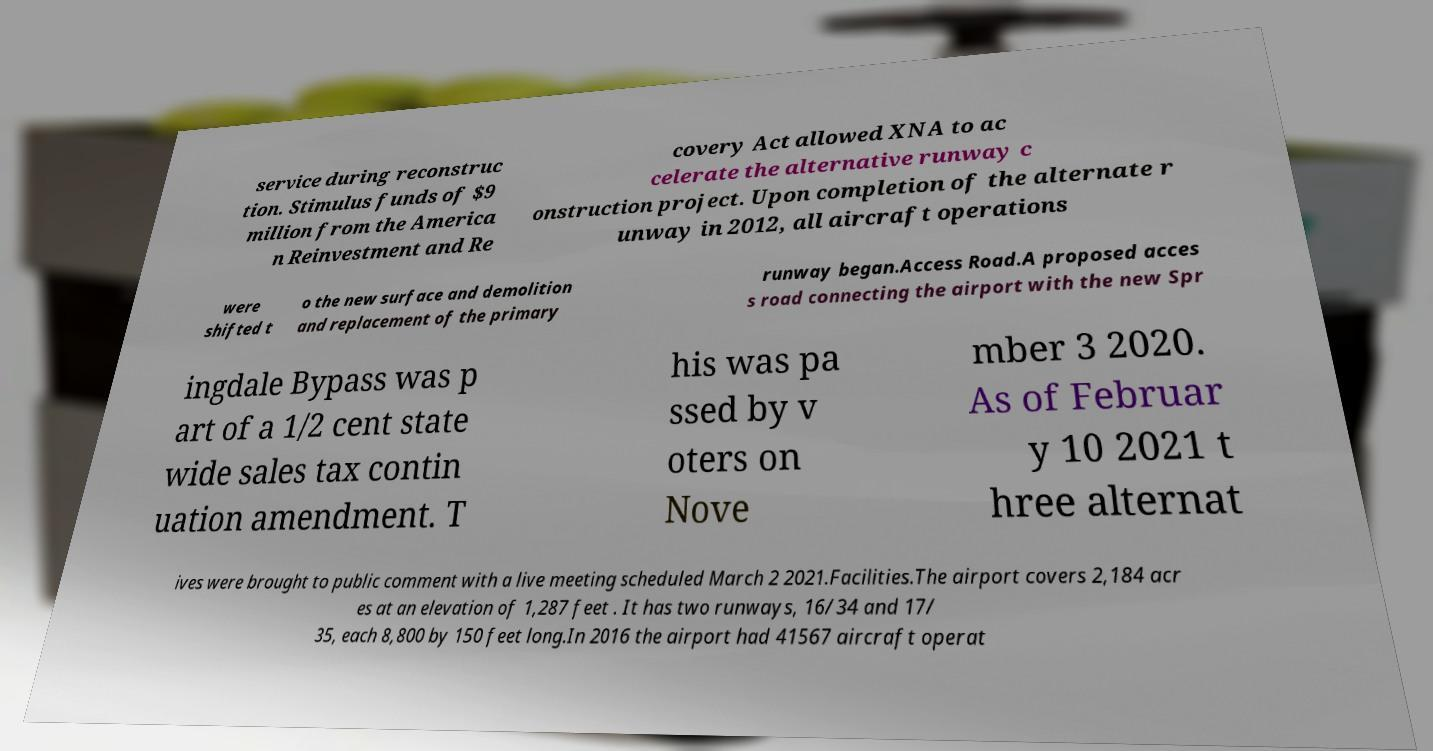Can you accurately transcribe the text from the provided image for me? service during reconstruc tion. Stimulus funds of $9 million from the America n Reinvestment and Re covery Act allowed XNA to ac celerate the alternative runway c onstruction project. Upon completion of the alternate r unway in 2012, all aircraft operations were shifted t o the new surface and demolition and replacement of the primary runway began.Access Road.A proposed acces s road connecting the airport with the new Spr ingdale Bypass was p art of a 1/2 cent state wide sales tax contin uation amendment. T his was pa ssed by v oters on Nove mber 3 2020. As of Februar y 10 2021 t hree alternat ives were brought to public comment with a live meeting scheduled March 2 2021.Facilities.The airport covers 2,184 acr es at an elevation of 1,287 feet . It has two runways, 16/34 and 17/ 35, each 8,800 by 150 feet long.In 2016 the airport had 41567 aircraft operat 